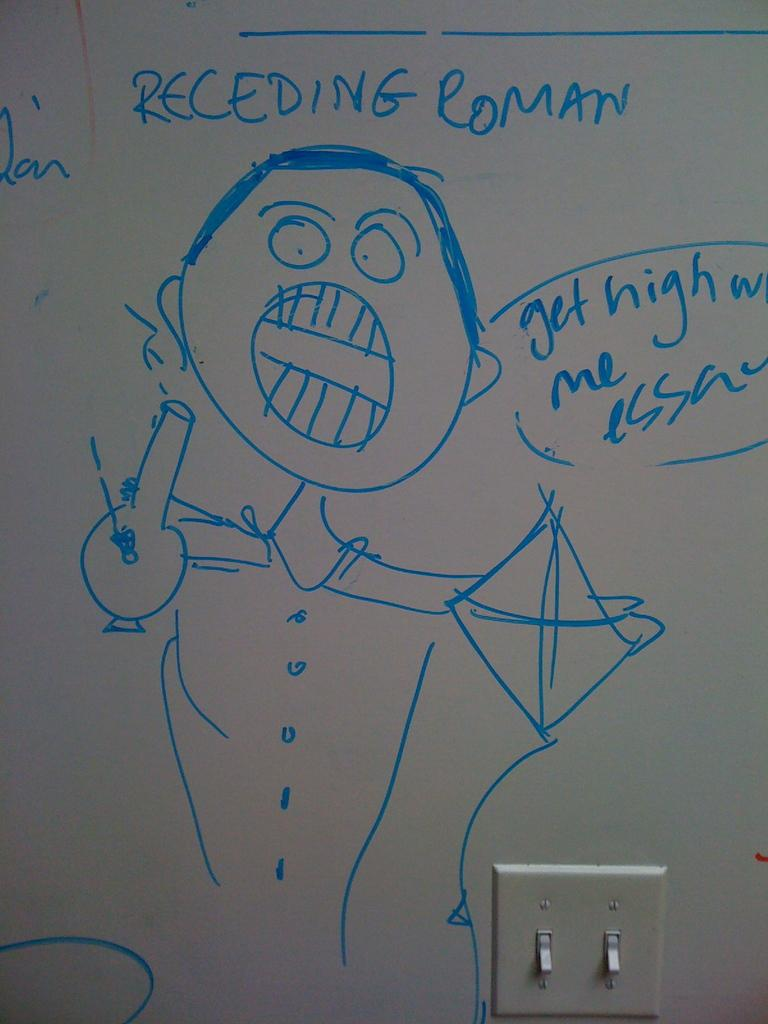<image>
Share a concise interpretation of the image provided. A drawing with blue marker on a white board of a character named Receding Roman 